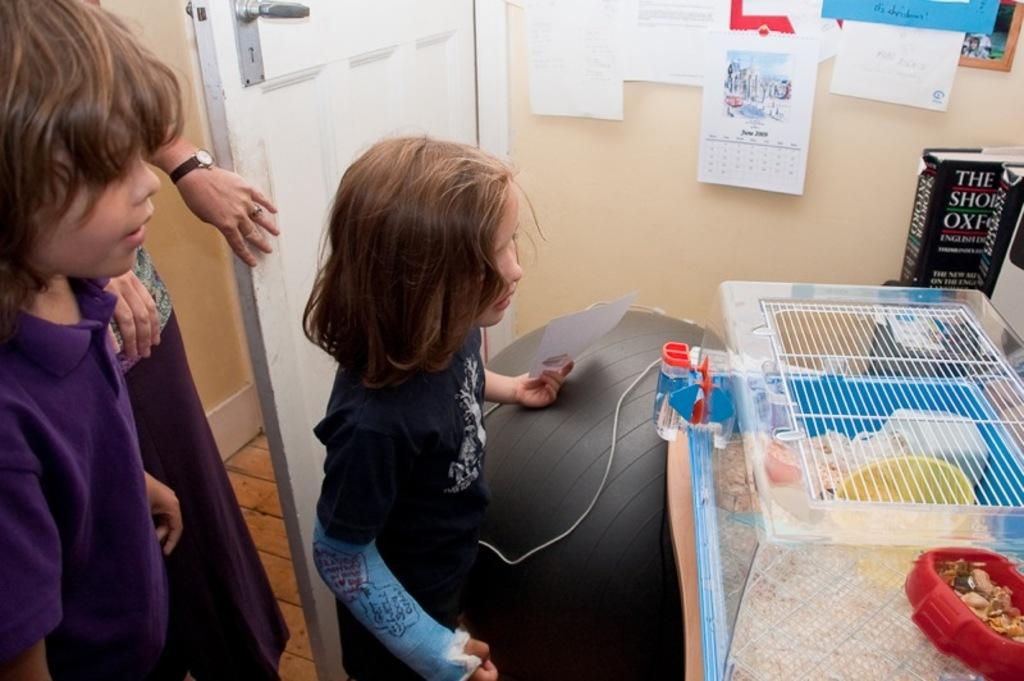<image>
Summarize the visual content of the image. A calendar in the background shows that it is June 2009 